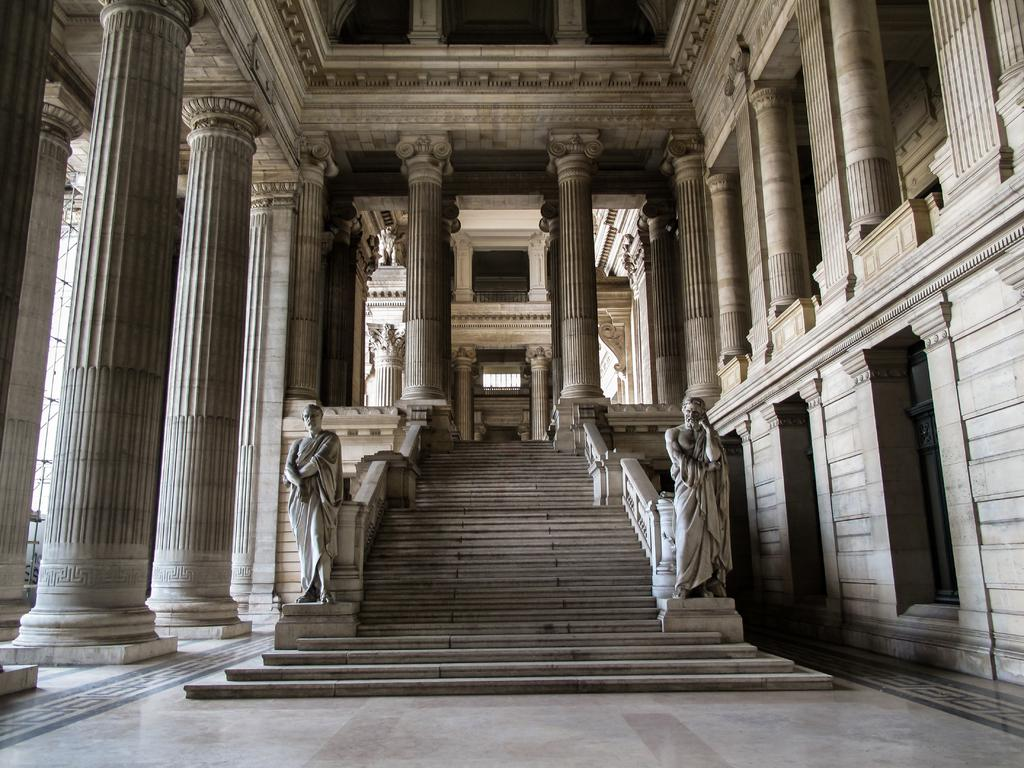What is the main feature in the center of the image? There are stairs in the center of the image. What can be seen beside the stairs? There are statues and pillars beside the stairs. Are there any decorative elements on the walls? Yes, there are engravings on the walls. What is at the bottom of the image? There is a floor at the bottom of the image. Where is the faucet located in the image? There is no faucet present in the image. Can you see any cats playing chess in the image? There are no cats or chess pieces visible in the image. 